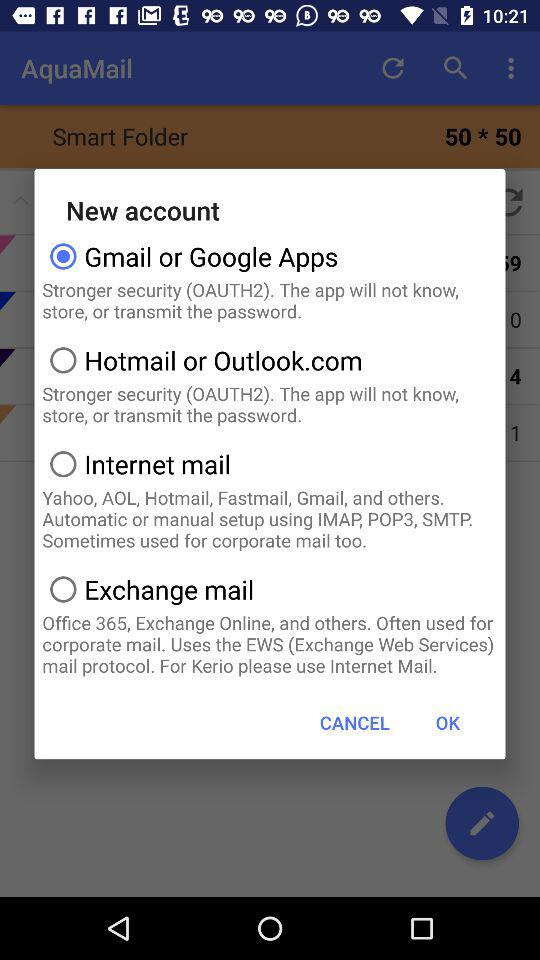Which account is selected? The selected account is "Gmail or Google Apps". 